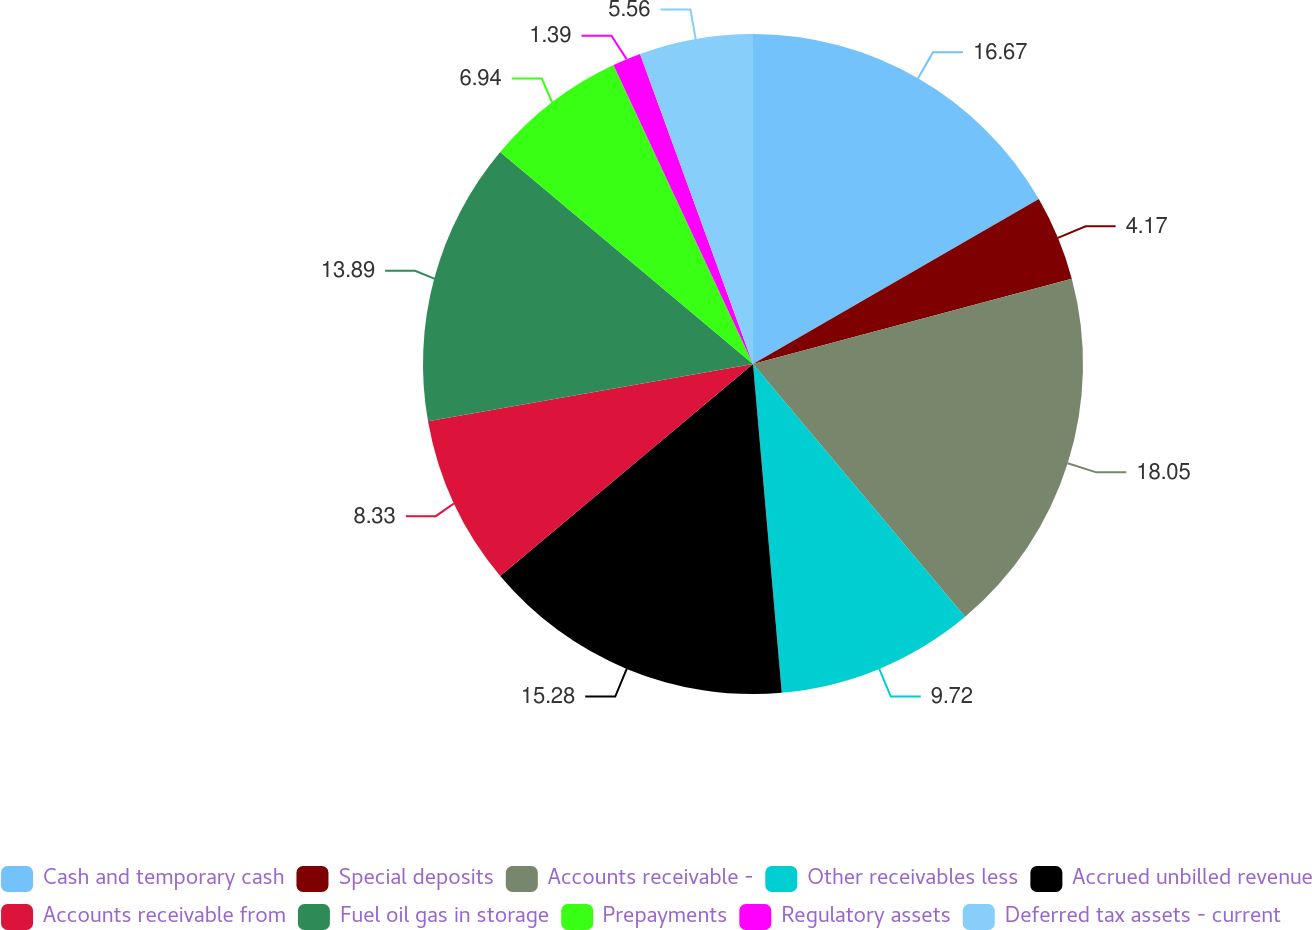Convert chart to OTSL. <chart><loc_0><loc_0><loc_500><loc_500><pie_chart><fcel>Cash and temporary cash<fcel>Special deposits<fcel>Accounts receivable -<fcel>Other receivables less<fcel>Accrued unbilled revenue<fcel>Accounts receivable from<fcel>Fuel oil gas in storage<fcel>Prepayments<fcel>Regulatory assets<fcel>Deferred tax assets - current<nl><fcel>16.67%<fcel>4.17%<fcel>18.05%<fcel>9.72%<fcel>15.28%<fcel>8.33%<fcel>13.89%<fcel>6.94%<fcel>1.39%<fcel>5.56%<nl></chart> 